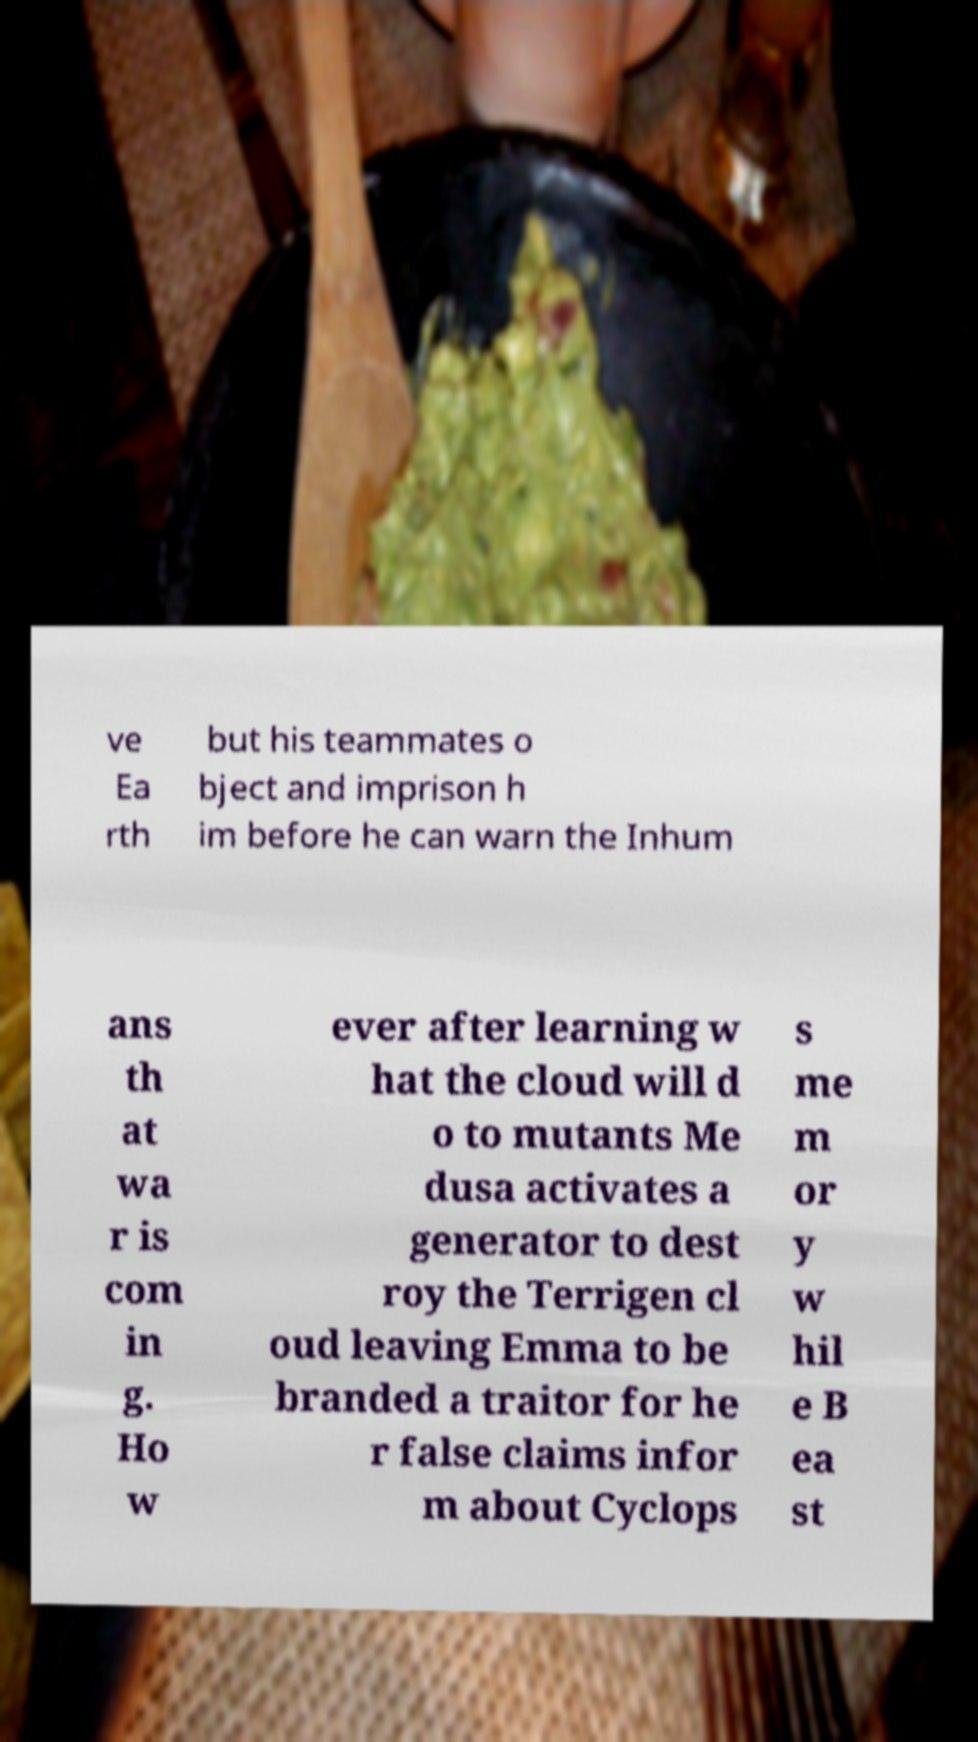I need the written content from this picture converted into text. Can you do that? ve Ea rth but his teammates o bject and imprison h im before he can warn the Inhum ans th at wa r is com in g. Ho w ever after learning w hat the cloud will d o to mutants Me dusa activates a generator to dest roy the Terrigen cl oud leaving Emma to be branded a traitor for he r false claims infor m about Cyclops s me m or y w hil e B ea st 